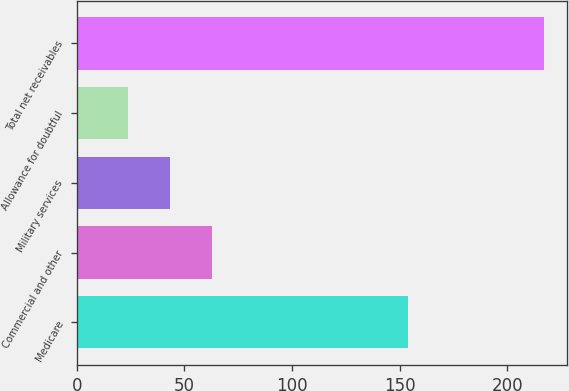Convert chart to OTSL. <chart><loc_0><loc_0><loc_500><loc_500><bar_chart><fcel>Medicare<fcel>Commercial and other<fcel>Military services<fcel>Allowance for doubtful<fcel>Total net receivables<nl><fcel>154<fcel>62.6<fcel>43.3<fcel>24<fcel>217<nl></chart> 